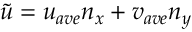Convert formula to latex. <formula><loc_0><loc_0><loc_500><loc_500>\tilde { u } = u _ { a v e } n _ { x } + v _ { a v e } n _ { y }</formula> 